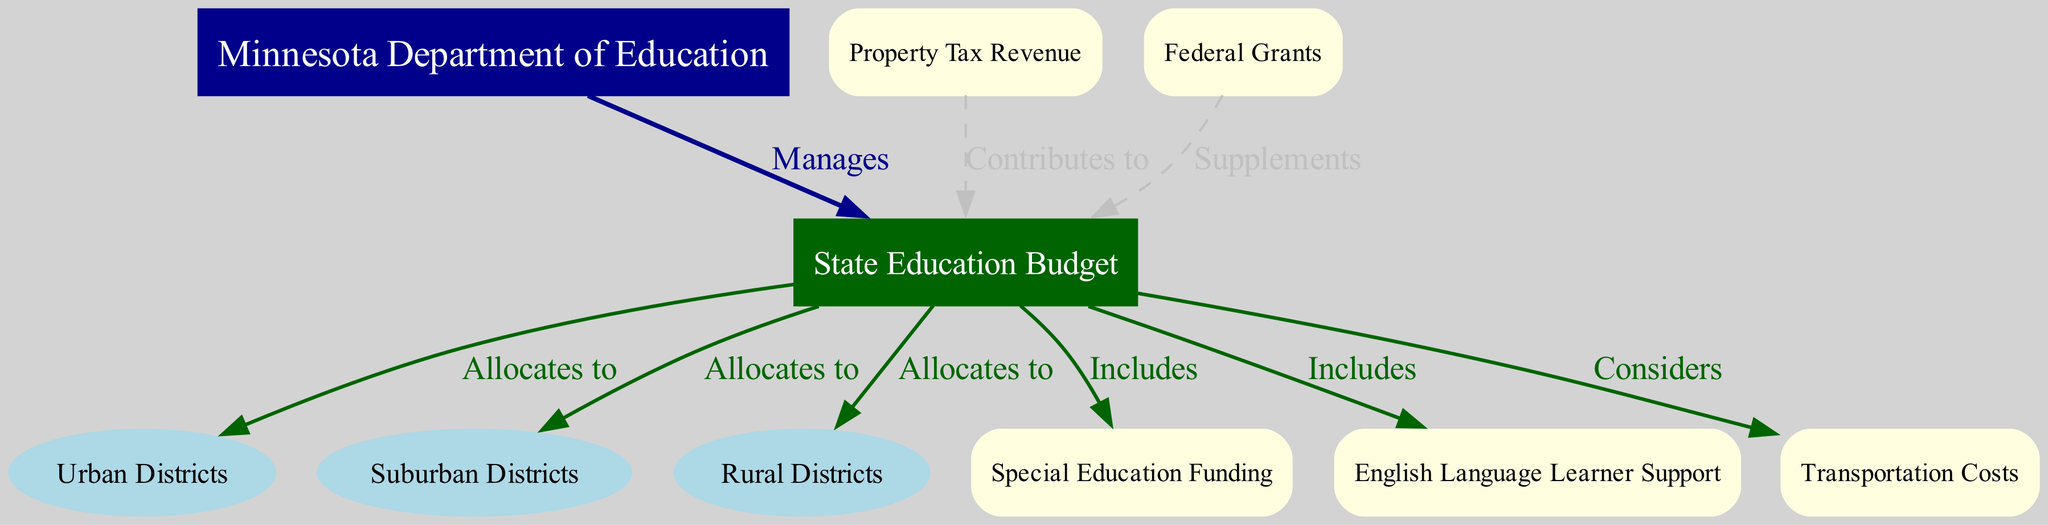What is the node that manages the education funding in Minnesota? The diagram identifies "Minnesota Department of Education" as the node that manages the education funding, as indicated by the directed edge labeled "Manages" pointing from that node.
Answer: Minnesota Department of Education How many districts does the State Education Budget allocate to? The diagram shows that the "State Education Budget" node allocates funds to three districts: "Urban Districts," "Suburban Districts," and "Rural Districts," connecting to each through directed edges labeled "Allocates to."
Answer: Three What type of funding is included in the State Education Budget? The diagram indicates that the "State Education Budget" includes "Special Education Funding" and "English Language Learner Support," as shown by the edges labeled "Includes" connecting to these nodes.
Answer: Special Education Funding, English Language Learner Support Which revenue contributes to the State Education Budget? The diagram shows "Property Tax Revenue" contributing to the "State Education Budget," as indicated by the directed edge labeled "Contributes to."
Answer: Property Tax Revenue What are the factors that the State Education Budget considers? The diagram illustrates that the "State Education Budget" considers "Transportation Costs", as demonstrated by the edge labeled "Considers" connecting to this node.
Answer: Transportation Costs How does Federal Grants relate to the State Education Budget? The diagram shows that "Federal Grants" supplements the "State Education Budget" through a directed edge labeled "Supplements," indicating an additive relationship.
Answer: Supplements Which districts receive funding from the State Education Budget? The diagram clearly indicates that the State Education Budget allocates funds to "Urban Districts," "Suburban Districts," and "Rural Districts," as shown by the three edges labeled "Allocates to."
Answer: Urban Districts, Suburban Districts, Rural Districts How does the Property Tax Revenue interact with education funding? The diagram indicates that "Property Tax Revenue" contributes to the "State Education Budget," suggesting that it plays a fundamental role in providing resources for education across the state.
Answer: Contributes to What relationships are indicated by edges concerning the State Education Budget? The edges related to the "State Education Budget" indicate "Allocates to" for districts, "Includes" for specific funding types, and "Considers" for costs, reflecting various interactions with nodes representing other entities and categories.
Answer: Allocates to, Includes, Considers 